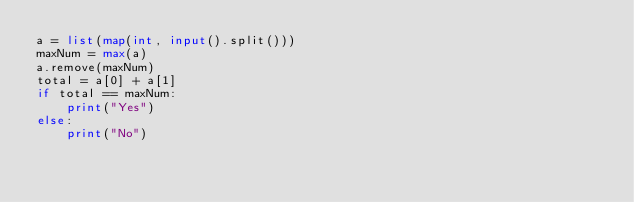Convert code to text. <code><loc_0><loc_0><loc_500><loc_500><_Python_>a = list(map(int, input().split()))
maxNum = max(a)
a.remove(maxNum)
total = a[0] + a[1]
if total == maxNum: 
    print("Yes")
else: 
    print("No")
</code> 